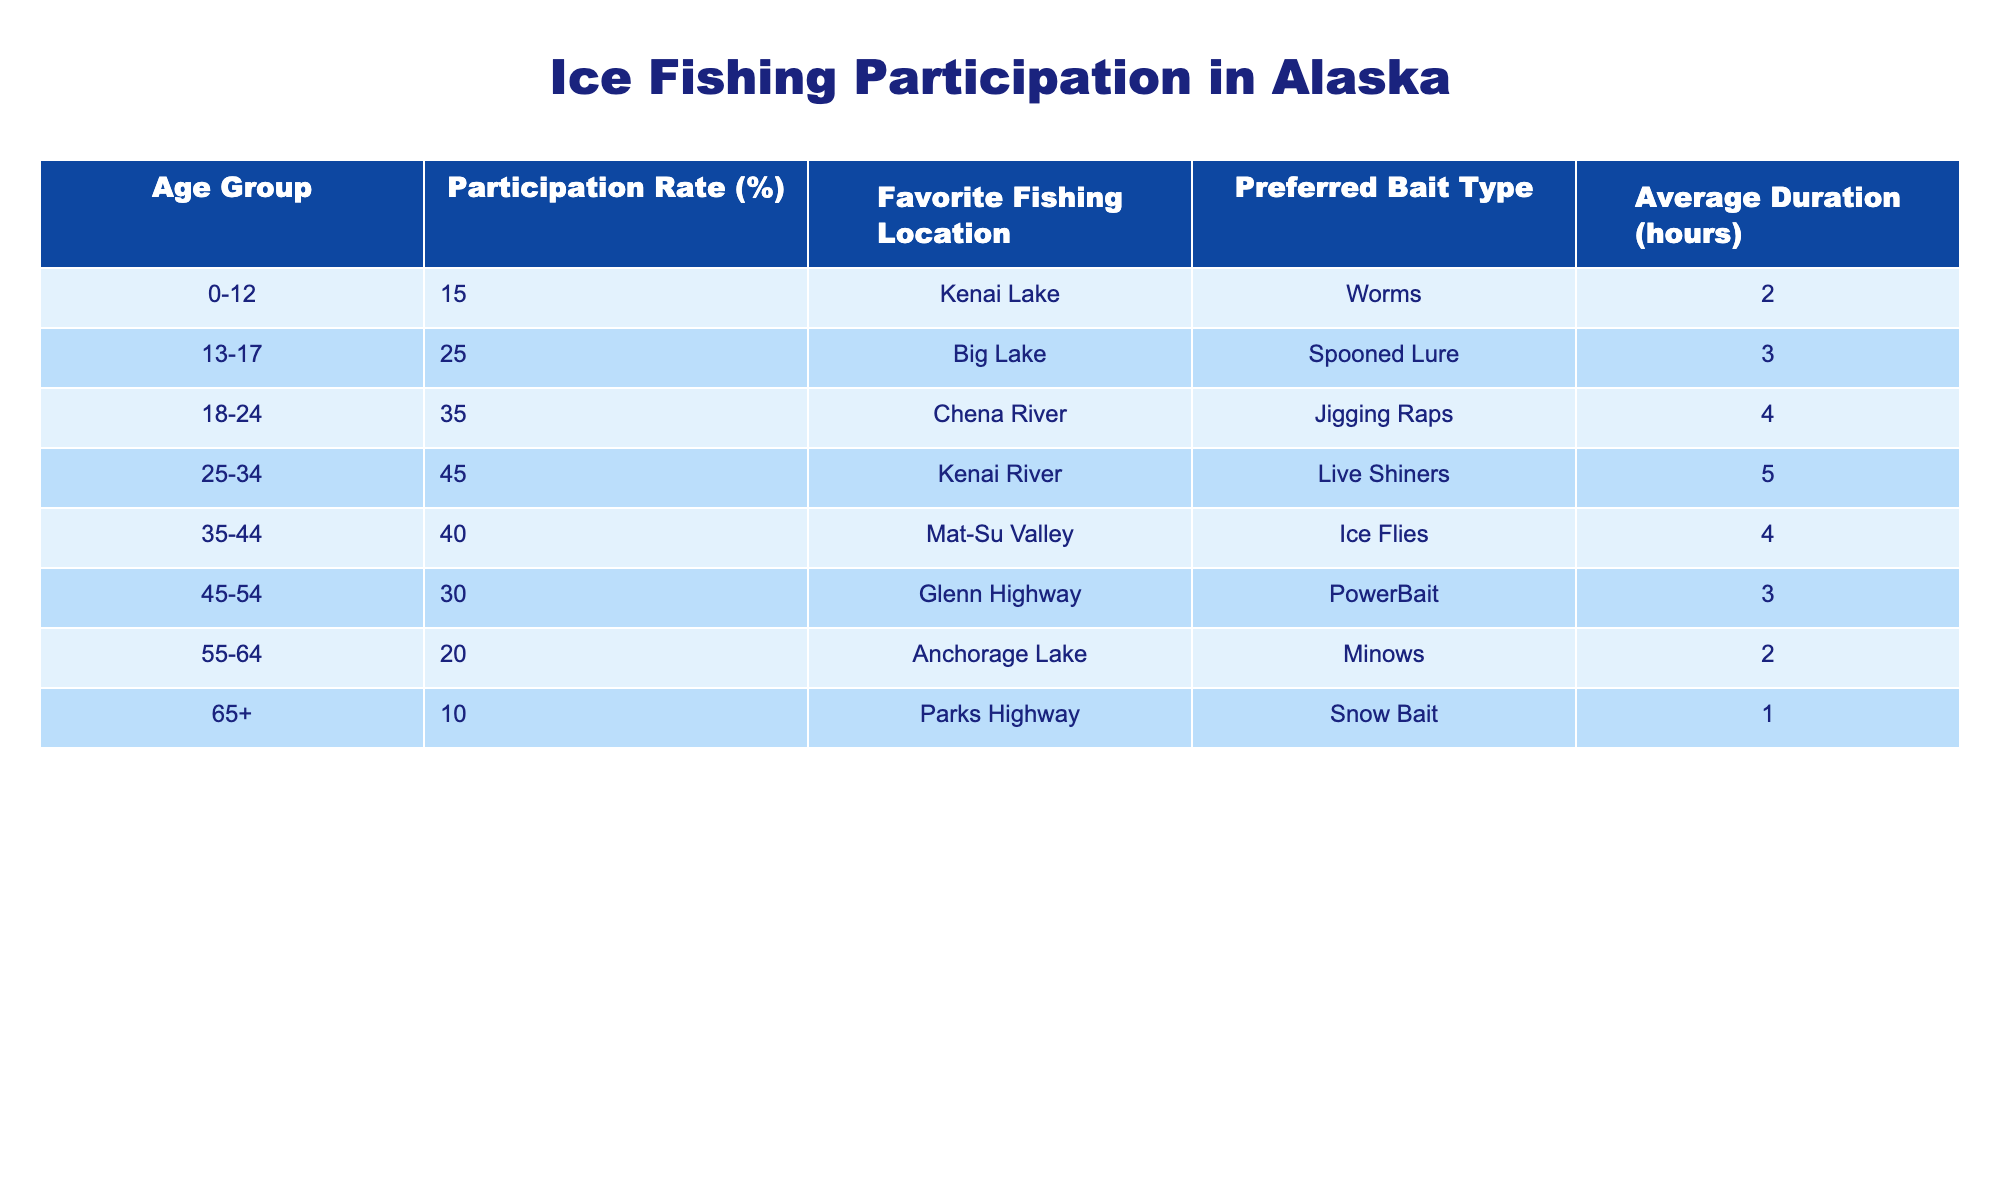What is the participation rate for the 25-34 age group? The participation rate for the 25-34 age group is directly stated in the table. It shows 45%.
Answer: 45% Which age group has the highest participation rate? By comparing the participation rates across all age groups in the table, the 25-34 age group has the highest participation rate at 45%.
Answer: 25-34 What is the average duration of ice fishing for participants aged 18-24? The table lists the average duration for the 18-24 age group as 4 hours.
Answer: 4 hours Is the favorite fishing location for participants aged 55-64 the same as for those aged 35-44? According to the table, participants aged 55-64 favor Anchorage Lake, while those aged 35-44 prefer Mat-Su Valley, therefore, it is not the same.
Answer: No Calculate the difference in participation rates between the 35-44 age group and the 65+ age group. The participation rate for the 35-44 age group is 40% and for the 65+ age group is 10%. To find the difference, subtract: 40% - 10% = 30%.
Answer: 30% What is the total participation rate percentage for all age groups combined? To calculate the total participation rate, add the individual participation rates together: 15 + 25 + 35 + 45 + 40 + 30 + 20 + 10 = 220%. Since there are 8 age groups, the average participation rate would be 220% / 8 = 27.5%.
Answer: 27.5% Which bait type is preferred by the youngest age group? The table indicates that the preferred bait type for the 0-12 age group is worms.
Answer: Worms Is the average duration of ice fishing for the 45-54 age group longer than that for the 55-64 age group? The average duration for the 45-54 age group is 3 hours, while for the 55-64 age group, it is 2 hours. Since 3 is greater than 2, the statement is true.
Answer: Yes What is the favorite fishing location for the age group with the lowest participation rate? The age group with the lowest participation rate is 65+, and their favorite fishing location is Parks Highway according to the table.
Answer: Parks Highway How many age groups have a participation rate below 30%? The age groups with participation rates below 30% are 55-64 (20%) and 65+ (10%). Therefore, there are 2 age groups in total.
Answer: 2 What is the average age group's participation rate among those aged 35-44 and 45-54? The participation rates are 40% for 35-44 and 30% for 45-54. To find the average: (40% + 30%) / 2 = 35%.
Answer: 35% 